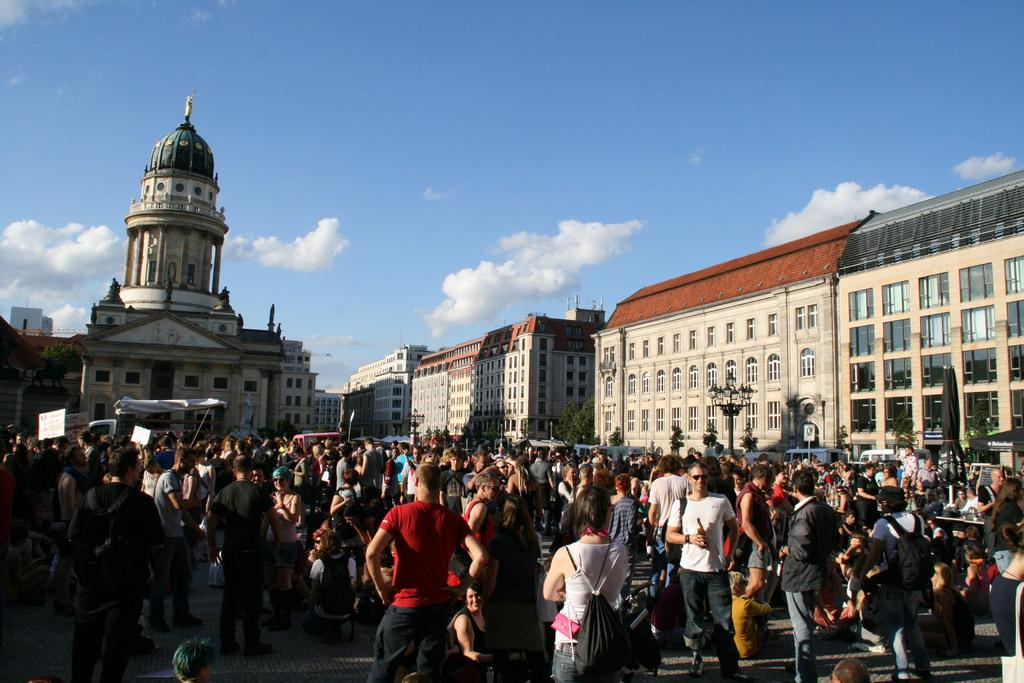How many people are in the image? There is a group of people in the image. What is the position of the people in the image? The people are standing on the ground. What can be seen in the background of the image? There are buildings, street lights, and the sky visible in the background of the image. Are there any other objects in the background of the image? Yes, there are other objects in the background of the image. What type of oven is being used by the people in the image? There is no oven present in the image; the people are standing on the ground. What emotion are the people expressing in the image? The image does not show any specific emotions being expressed by the people. 